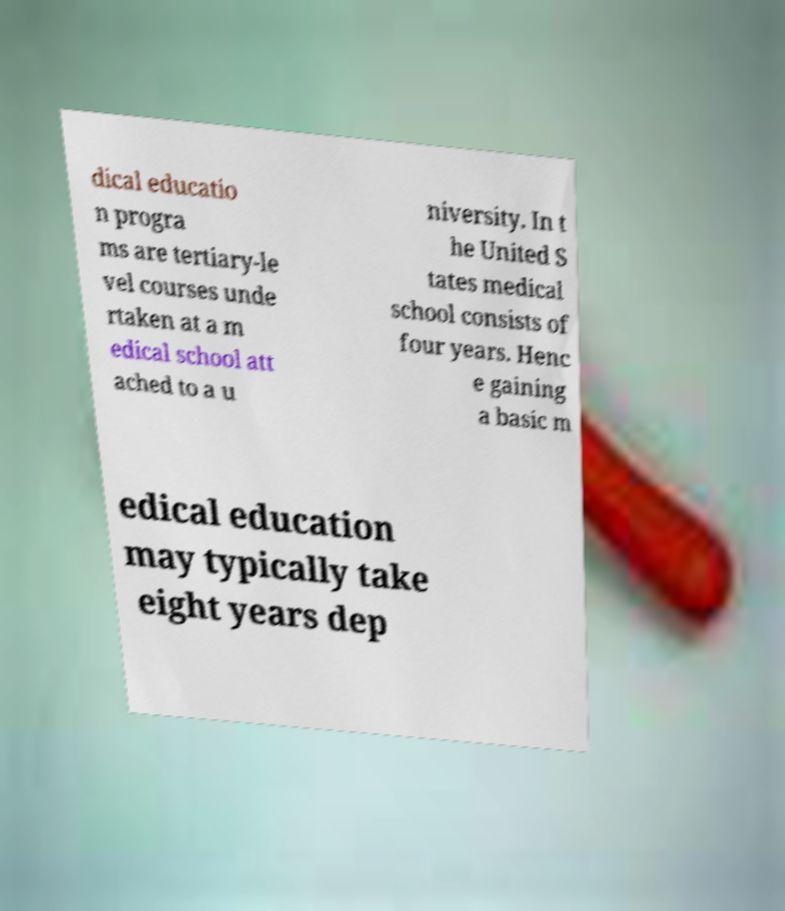What messages or text are displayed in this image? I need them in a readable, typed format. dical educatio n progra ms are tertiary-le vel courses unde rtaken at a m edical school att ached to a u niversity. In t he United S tates medical school consists of four years. Henc e gaining a basic m edical education may typically take eight years dep 